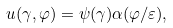<formula> <loc_0><loc_0><loc_500><loc_500>u ( \gamma , \varphi ) = \psi ( \gamma ) \alpha ( \varphi / \varepsilon ) ,</formula> 